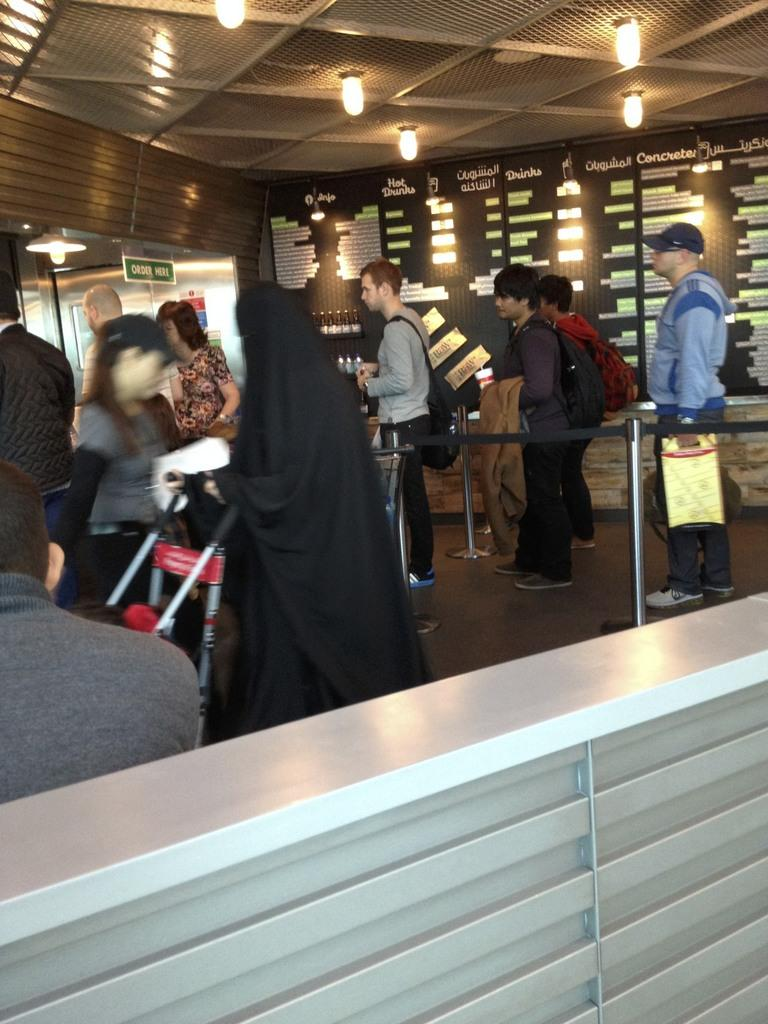What type of barrier is present in the image? There is a metal fence in the image. What is the surface that the people are standing on? The people are standing on the floor in the image. What can be seen at the top of the image? There are lights visible at the top of the image. What is located in the background of the image? There is a board in the background of the image. Where are the chickens located in the image? There are no chickens present in the image. What type of transportation is shown in the image? There is no transportation, such as trains, depicted in the image. 